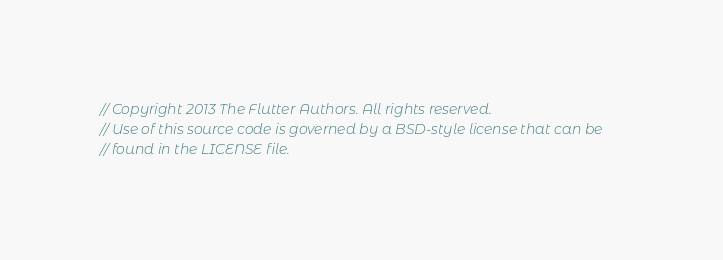Convert code to text. <code><loc_0><loc_0><loc_500><loc_500><_C_>// Copyright 2013 The Flutter Authors. All rights reserved.
// Use of this source code is governed by a BSD-style license that can be
// found in the LICENSE file.
</code> 